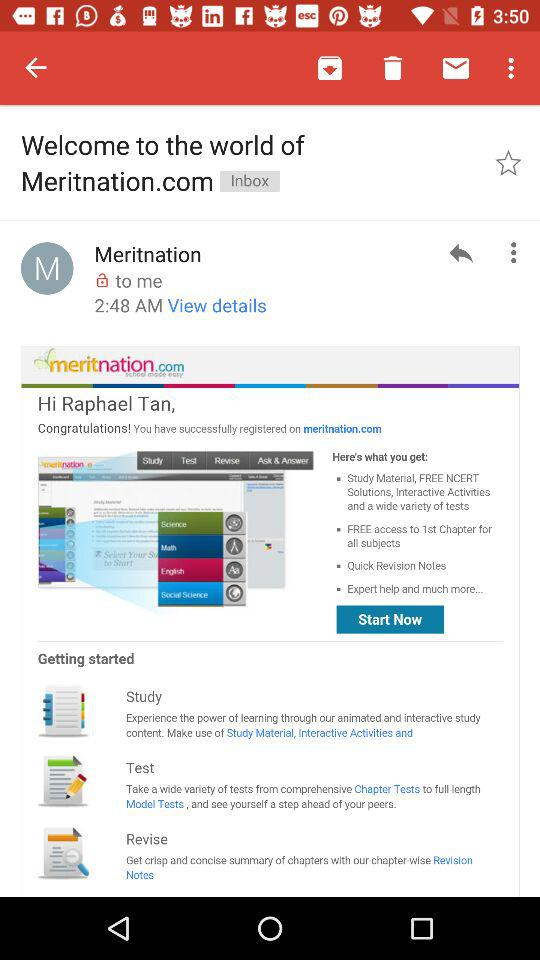From whom is the mail received? The mail is received from "Meritnation". 